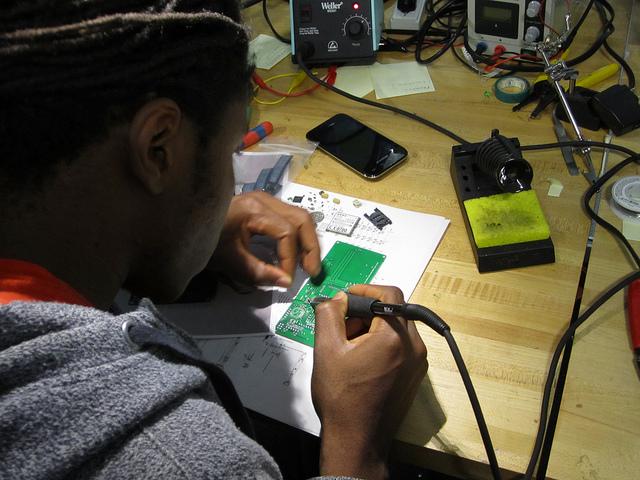Is there a phone in the photo?
Quick response, please. Yes. What instrument is this person using?
Quick response, please. Soldering iron. What color is the man's shirt?
Quick response, please. Orange. 